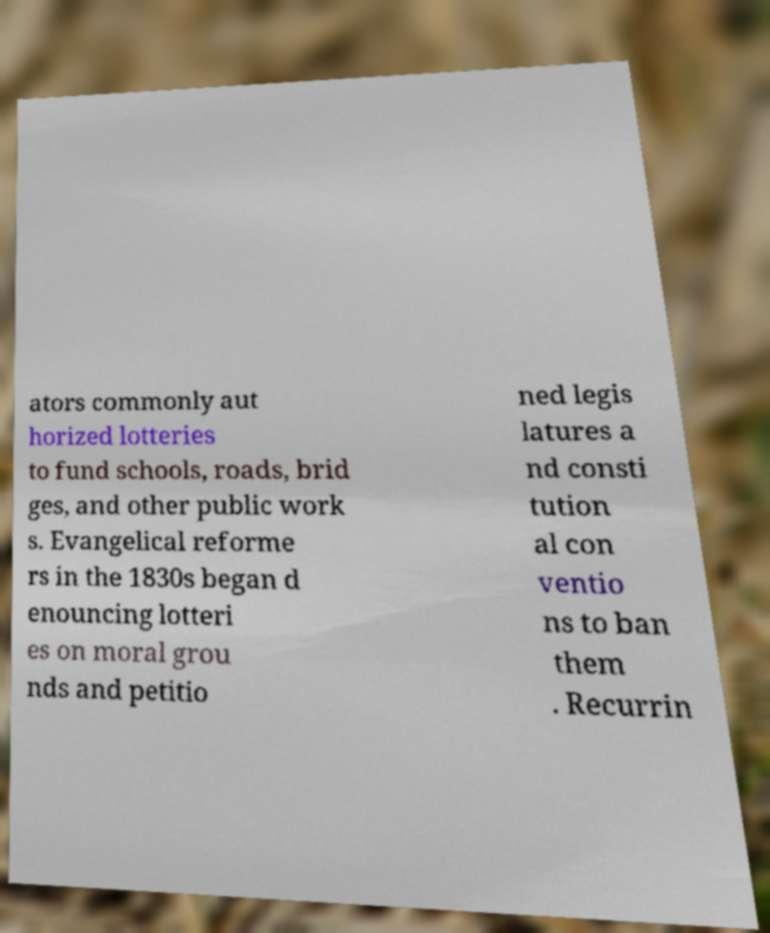Please identify and transcribe the text found in this image. ators commonly aut horized lotteries to fund schools, roads, brid ges, and other public work s. Evangelical reforme rs in the 1830s began d enouncing lotteri es on moral grou nds and petitio ned legis latures a nd consti tution al con ventio ns to ban them . Recurrin 